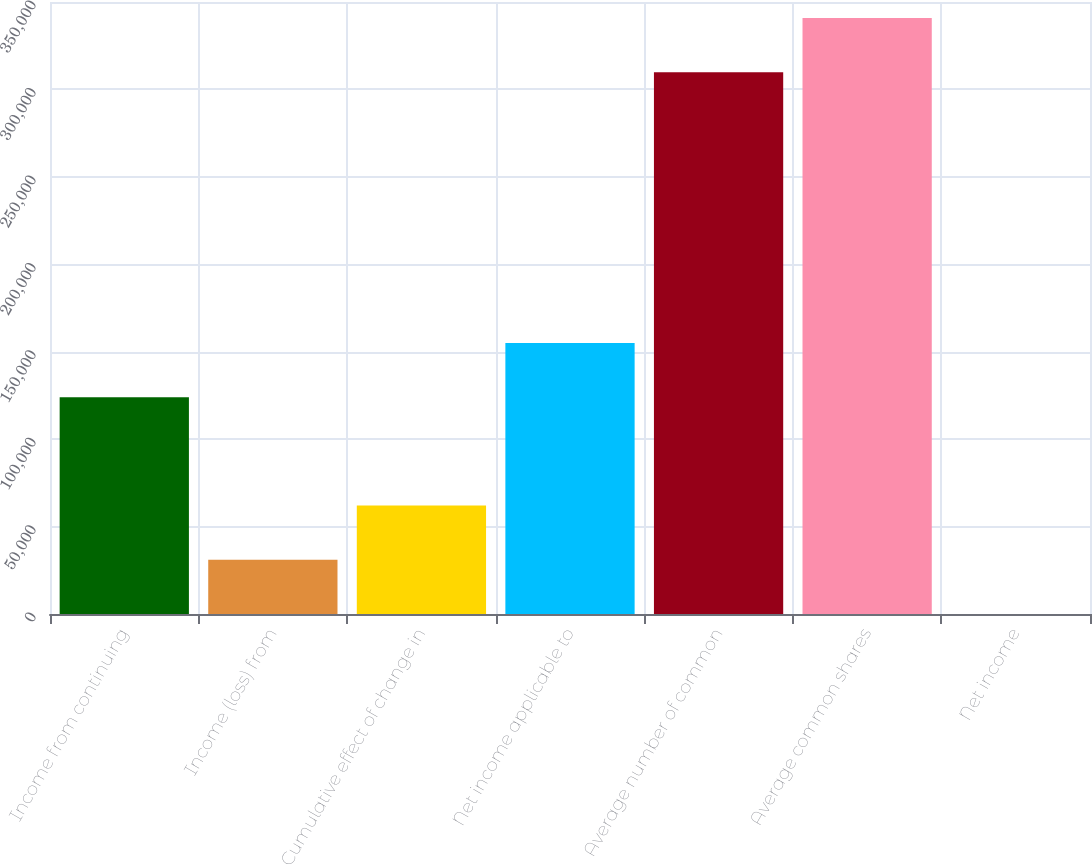Convert chart. <chart><loc_0><loc_0><loc_500><loc_500><bar_chart><fcel>Income from continuing<fcel>Income (loss) from<fcel>Cumulative effect of change in<fcel>Net income applicable to<fcel>Average number of common<fcel>Average common shares<fcel>Net income<nl><fcel>123981<fcel>30996.6<fcel>61991.5<fcel>154976<fcel>309792<fcel>340787<fcel>1.66<nl></chart> 